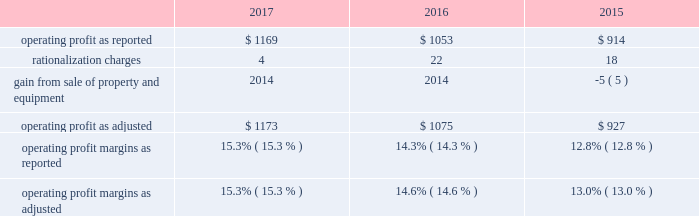Affected by lower sales volume of cabinets , the divestiture of our arrow and moores businesses , and an unfavorable sales mix of international plumbing products , which , in aggregate , decreased sales by approximately two percent compared to 2016 .
Net sales for 2016 were positively affected by increased sales volume of plumbing products , paints and other coating products and builders' hardware , which , in aggregate , increased sales by approximately five percent compared to 2015 .
Net sales for 2016 were also positively affected by favorable sales mix of cabinets and windows , and net selling price increases of north american windows and north american and international plumbing products , which , in aggregate , increased sales approximately one percent .
Net sales for 2016 were negatively affected by lower sales volume of cabinets and lower net selling prices of paints and other coating products , which , in aggregate , decreased sales by approximately two percent .
Net sales for 2015 were positively affected by increased sales volume of plumbing products , paints and other coating products , windows and builders' hardware .
Net sales for 2015 were also positively affected by net selling price increases of plumbing products , cabinets and windows , as well as sales mix of north american cabinets and windows .
Net sales for 2015 were negatively affected by lower sales volume of cabinets and lower net selling prices of paints and other coating products .
Our gross profit margins were 34.2 percent , 33.4 percent and 31.5 percent in 2017 , 2016 and 2015 , respectively .
The 2017 and 2016 gross profit margins were positively impacted by increased sales volume , a more favorable relationship between net selling prices and commodity costs , and cost savings initiatives .
2016 gross profit margins were negatively impacted by an increase in warranty costs resulting from a change in our estimate of expected future warranty claim costs .
Selling , general and administrative expenses as a percent of sales were 18.9 percent in 2017 compared with 19.1 percent in 2016 and 18.7 percent in 2015 .
Selling , general and administrative expenses as a percent of sales in 2017 reflect increased sales and the effect of cost containment measures , partially offset by an increase in strategic growth investments , stock-based compensation , health insurance costs and trade show costs .
Selling , general and administrative expenses as a percent of sales in 2016 reflect strategic growth investments , erp system implementation costs and higher insurance costs .
The table reconciles reported operating profit to operating profit , as adjusted to exclude certain items , dollars in millions: .
Operating profit margins in 2017 and 2016 were positively affected by increased sales volume , cost savings initiatives , and a more favorable relationship between net selling prices and commodity costs .
Operating profit margin in 2017 was negatively impacted by an increase in strategic growth investments and certain other expenses , including stock-based compensation , health insurance costs , trade show costs and increased head count .
Operating profit margin in 2016 was negatively impacted by an increase in warranty costs by a business in our windows and other specialty products segment and an increase in strategic growth investments , as well as erp system implementation costs and higher insurance costs .
.......................................................... .
.................................................................. .
..................................... .
........................................................ .
............................................ .
............................................. .
What was the percent of the increase in the operating profit as reported from 2016 to 2017? 
Rationale: the operating profit as reported increased by 11% from 2016 to 2017
Computations: ((1169 / 1053) / 1053)
Answer: 0.00105. 